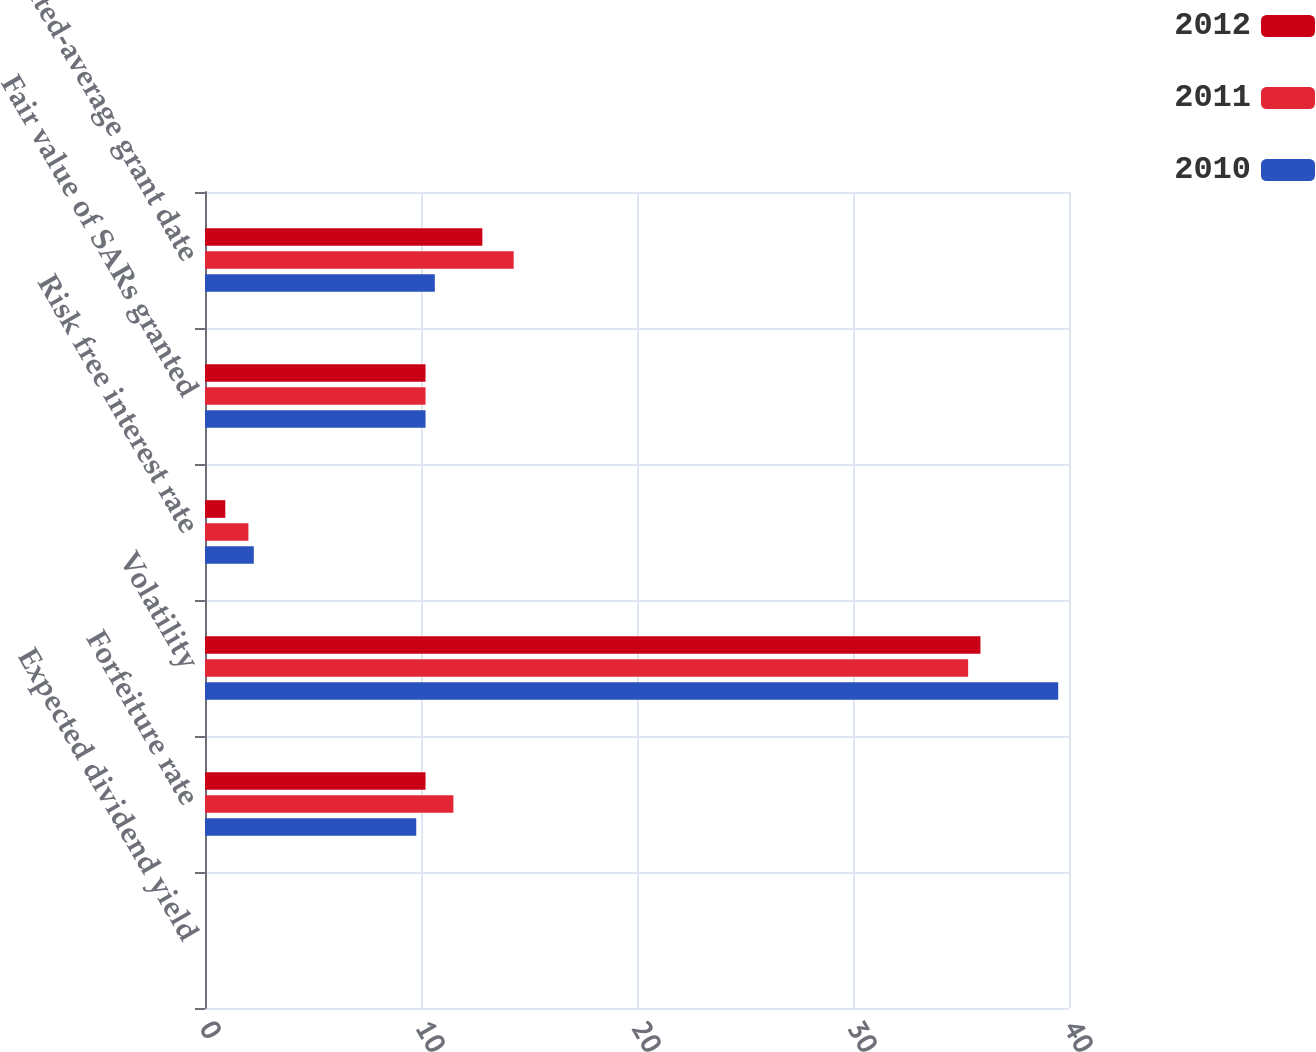Convert chart. <chart><loc_0><loc_0><loc_500><loc_500><stacked_bar_chart><ecel><fcel>Expected dividend yield<fcel>Forfeiture rate<fcel>Volatility<fcel>Risk free interest rate<fcel>Fair value of SARs granted<fcel>Weighted-average grant date<nl><fcel>2012<fcel>0<fcel>10.21<fcel>35.9<fcel>0.94<fcel>10.21<fcel>12.84<nl><fcel>2011<fcel>0<fcel>11.5<fcel>35.33<fcel>2.01<fcel>10.21<fcel>14.29<nl><fcel>2010<fcel>0<fcel>9.78<fcel>39.5<fcel>2.26<fcel>10.21<fcel>10.64<nl></chart> 